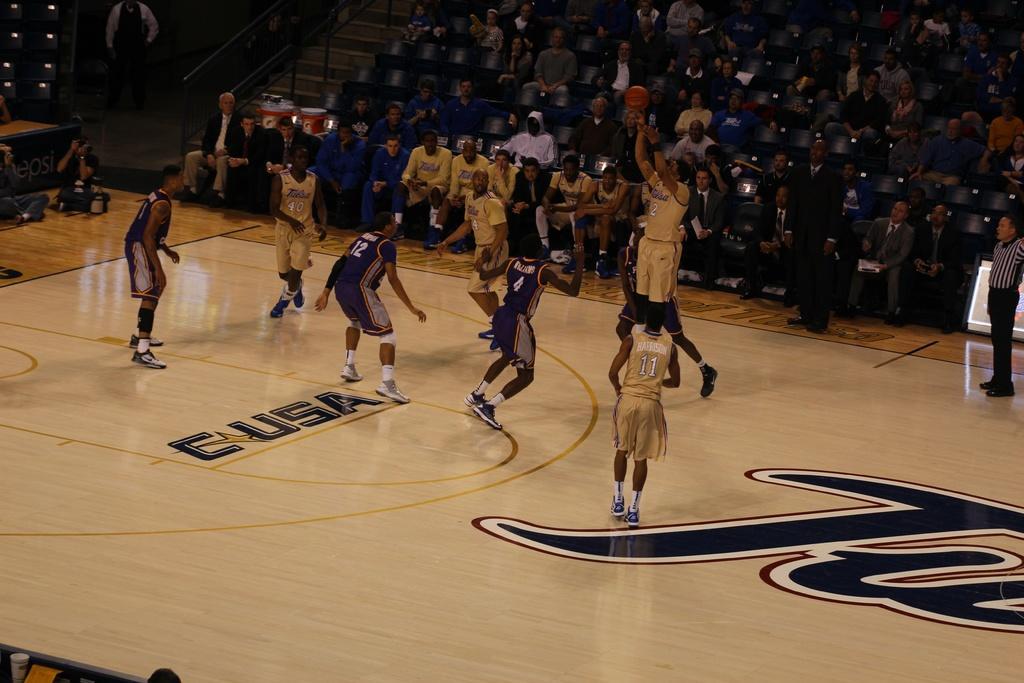Could you give a brief overview of what you see in this image? In this image, I can see few people playing basketball game. On the right side of the image, there are two people standing. I can see groups of people sitting on the chairs. It looks like a basketball stadium. At the top of the image, I can see the stairs and a person standing. On the left side of the image, there are two people sitting on the floor. 